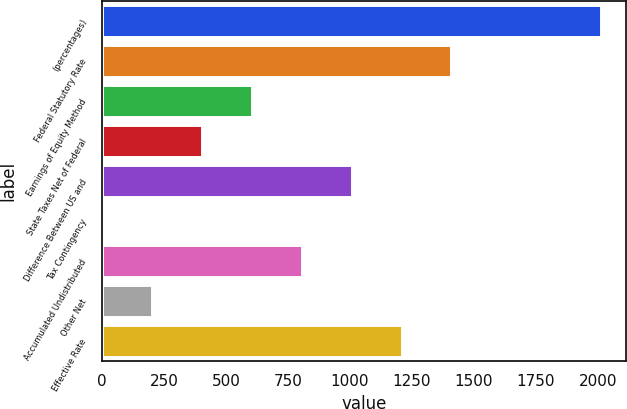<chart> <loc_0><loc_0><loc_500><loc_500><bar_chart><fcel>(percentages)<fcel>Federal Statutory Rate<fcel>Earnings of Equity Method<fcel>State Taxes Net of Federal<fcel>Difference Between US and<fcel>Tax Contingency<fcel>Accumulated Undistributed<fcel>Other Net<fcel>Effective Rate<nl><fcel>2014<fcel>1409.83<fcel>604.27<fcel>402.88<fcel>1007.05<fcel>0.1<fcel>805.66<fcel>201.49<fcel>1208.44<nl></chart> 